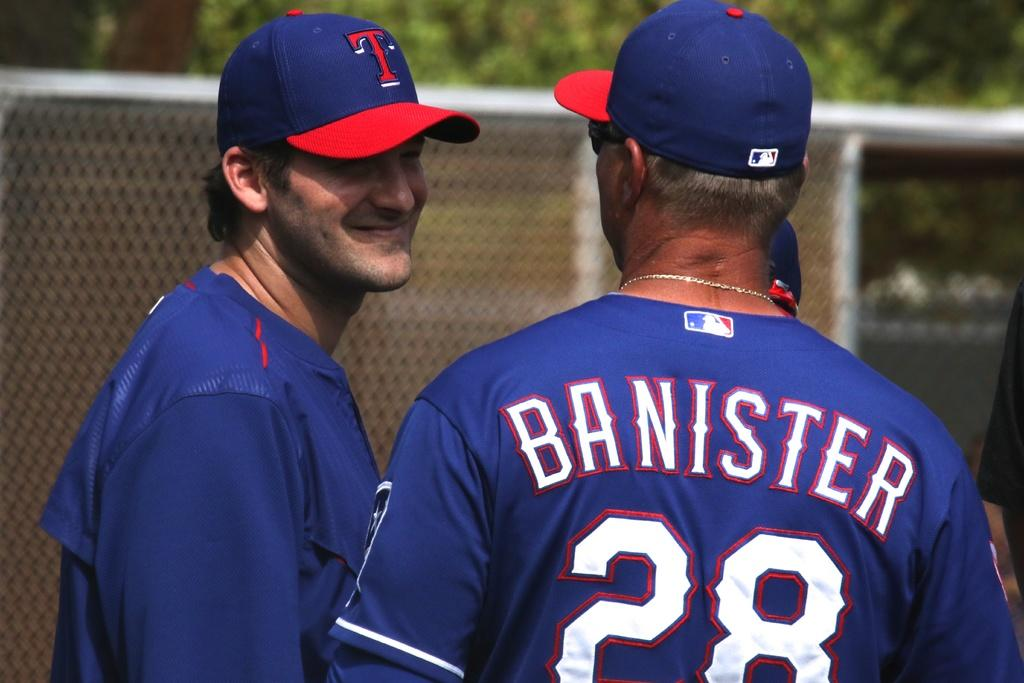<image>
Write a terse but informative summary of the picture. two baseball players speaking with banister's back facing the camera 